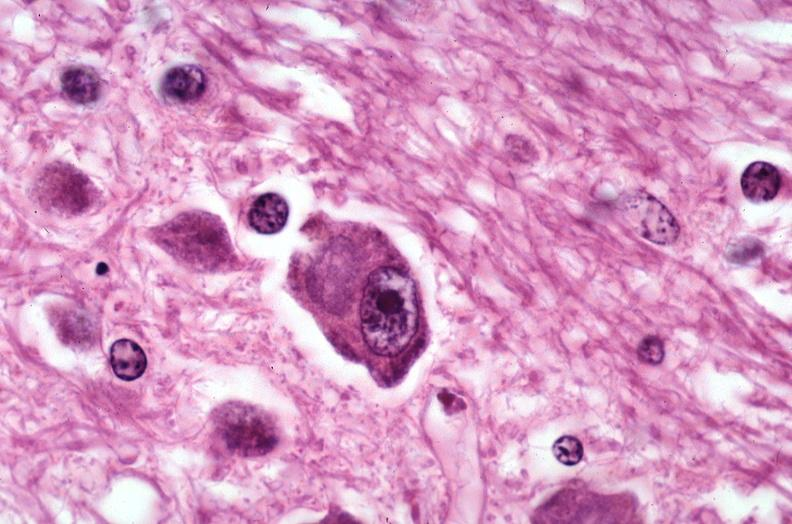does this image show brain, pick 's disease?
Answer the question using a single word or phrase. Yes 